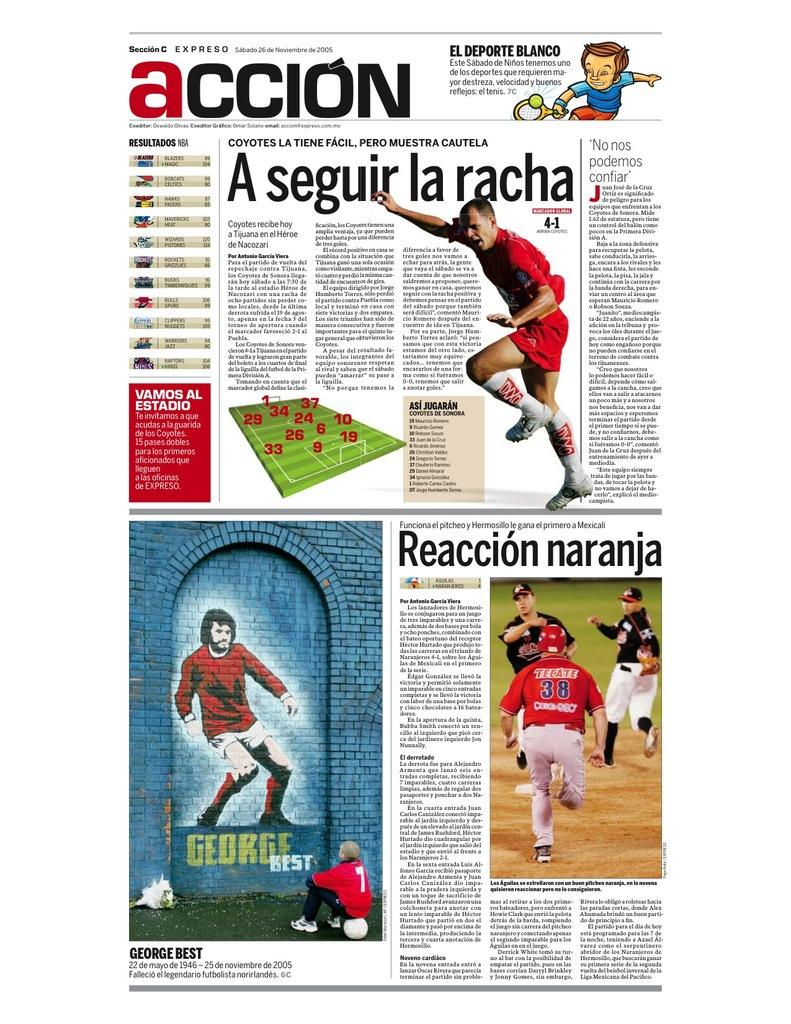<image>
Summarize the visual content of the image. The title of the newspaper is called Accion 